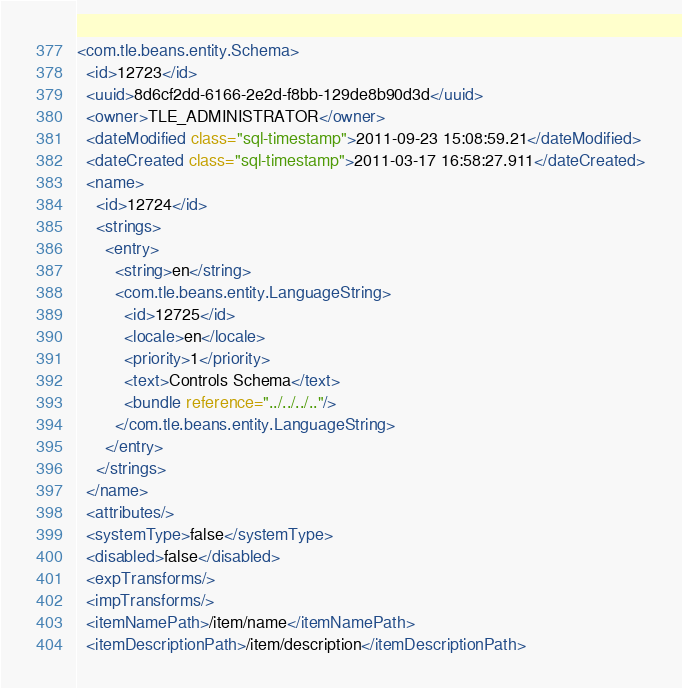<code> <loc_0><loc_0><loc_500><loc_500><_XML_><com.tle.beans.entity.Schema>
  <id>12723</id>
  <uuid>8d6cf2dd-6166-2e2d-f8bb-129de8b90d3d</uuid>
  <owner>TLE_ADMINISTRATOR</owner>
  <dateModified class="sql-timestamp">2011-09-23 15:08:59.21</dateModified>
  <dateCreated class="sql-timestamp">2011-03-17 16:58:27.911</dateCreated>
  <name>
    <id>12724</id>
    <strings>
      <entry>
        <string>en</string>
        <com.tle.beans.entity.LanguageString>
          <id>12725</id>
          <locale>en</locale>
          <priority>1</priority>
          <text>Controls Schema</text>
          <bundle reference="../../../.."/>
        </com.tle.beans.entity.LanguageString>
      </entry>
    </strings>
  </name>
  <attributes/>
  <systemType>false</systemType>
  <disabled>false</disabled>
  <expTransforms/>
  <impTransforms/>
  <itemNamePath>/item/name</itemNamePath>
  <itemDescriptionPath>/item/description</itemDescriptionPath></code> 